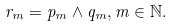<formula> <loc_0><loc_0><loc_500><loc_500>r _ { m } = p _ { m } \wedge q _ { m } , m \in \mathbb { N } .</formula> 